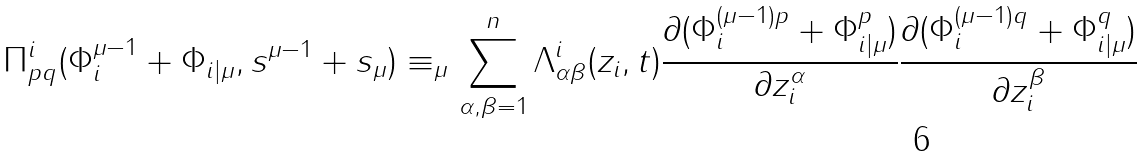<formula> <loc_0><loc_0><loc_500><loc_500>\Pi _ { p q } ^ { i } ( \Phi _ { i } ^ { \mu - 1 } + \Phi _ { i | \mu } , s ^ { \mu - 1 } + s _ { \mu } ) \equiv _ { \mu } \sum _ { \alpha , \beta = 1 } ^ { n } \Lambda _ { \alpha \beta } ^ { i } ( z _ { i } , t ) \frac { \partial ( \Phi _ { i } ^ { ( \mu - 1 ) p } + \Phi _ { i | \mu } ^ { p } ) } { \partial z _ { i } ^ { \alpha } } \frac { \partial ( \Phi _ { i } ^ { ( \mu - 1 ) q } + \Phi _ { i | \mu } ^ { q } ) } { \partial z _ { i } ^ { \beta } }</formula> 